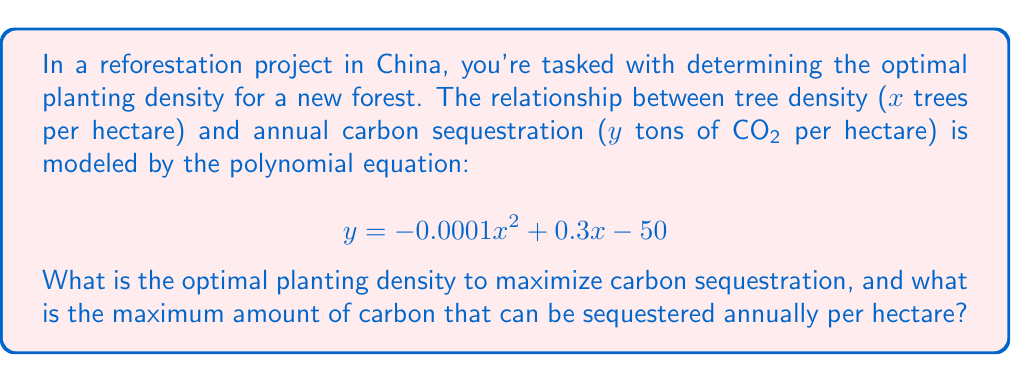Help me with this question. To solve this problem, we need to find the maximum point of the given quadratic function. This can be done by following these steps:

1. The given polynomial equation is in the form of a quadratic function:
   $$ y = ax^2 + bx + c $$
   where $a = -0.0001$, $b = 0.3$, and $c = -50$

2. For a quadratic function, the x-coordinate of the vertex (which represents the optimal planting density in this case) is given by the formula:
   $$ x = -\frac{b}{2a} $$

3. Substituting the values:
   $$ x = -\frac{0.3}{2(-0.0001)} = \frac{0.3}{0.0002} = 1500 $$

4. Therefore, the optimal planting density is 1500 trees per hectare.

5. To find the maximum carbon sequestration, we substitute this x-value back into the original equation:
   $$ y = -0.0001(1500)^2 + 0.3(1500) - 50 $$
   $$ = -0.0001(2,250,000) + 450 - 50 $$
   $$ = -225 + 450 - 50 $$
   $$ = 175 $$

Thus, the maximum amount of carbon that can be sequestered annually is 175 tons of CO2 per hectare.
Answer: The optimal planting density is 1500 trees per hectare, and the maximum carbon sequestration is 175 tons of CO2 per hectare annually. 